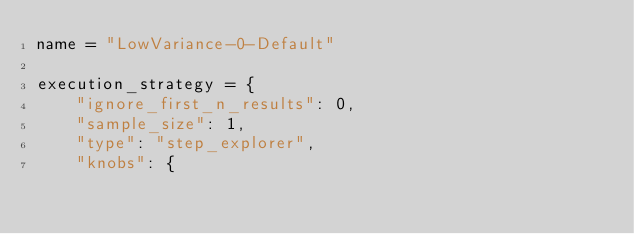<code> <loc_0><loc_0><loc_500><loc_500><_Python_>name = "LowVariance-0-Default"

execution_strategy = {
    "ignore_first_n_results": 0,
    "sample_size": 1,
    "type": "step_explorer",
    "knobs": {</code> 